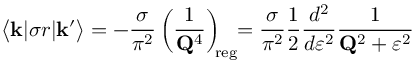Convert formula to latex. <formula><loc_0><loc_0><loc_500><loc_500>\Big < { k } | \sigma r | { k ^ { \prime } } \Big > = - \frac { \sigma } { \pi ^ { 2 } } \left ( \frac { 1 } { { Q } ^ { 4 } } \right ) _ { \, r e g } \, = \frac { \sigma } { \pi ^ { 2 } } \frac { 1 } { 2 } \frac { d ^ { 2 } } { d \varepsilon ^ { 2 } } \frac { 1 } { { Q } ^ { 2 } + \varepsilon ^ { 2 } }</formula> 